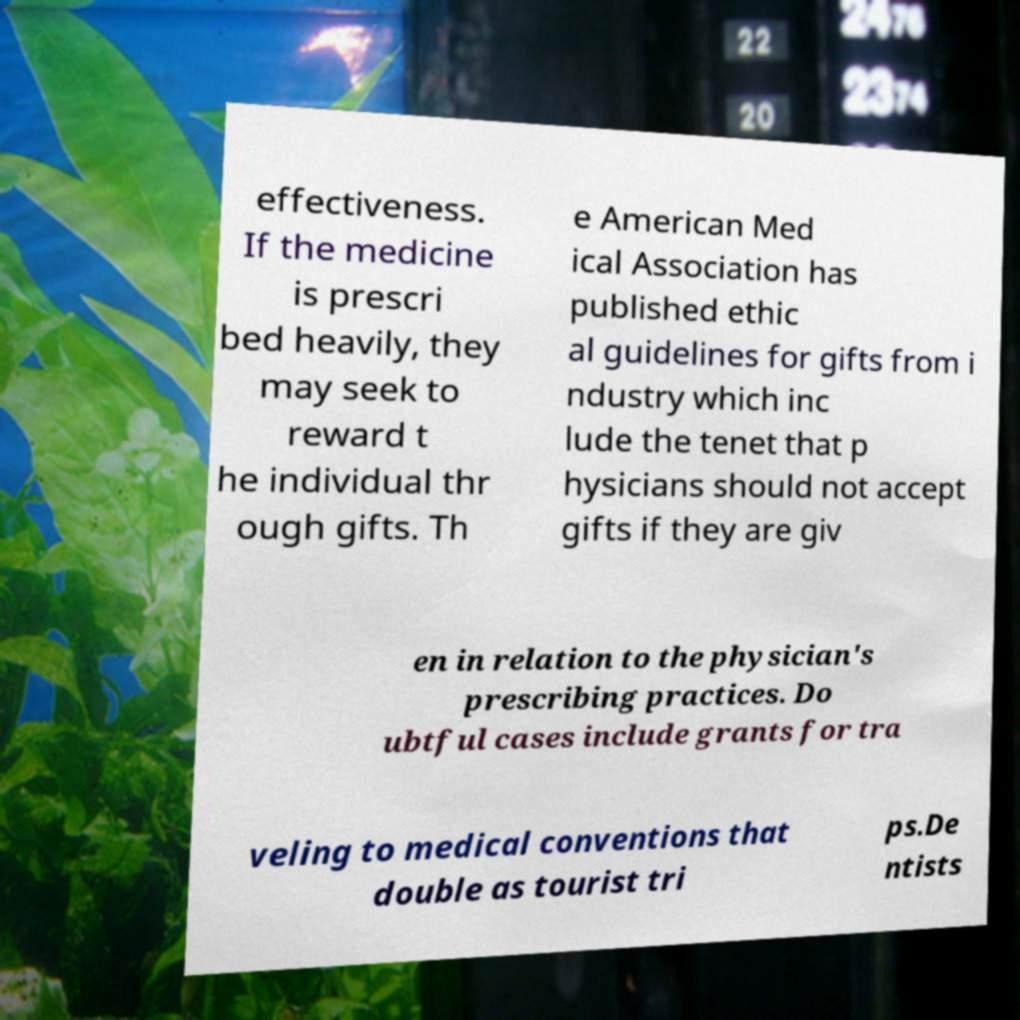Can you accurately transcribe the text from the provided image for me? effectiveness. If the medicine is prescri bed heavily, they may seek to reward t he individual thr ough gifts. Th e American Med ical Association has published ethic al guidelines for gifts from i ndustry which inc lude the tenet that p hysicians should not accept gifts if they are giv en in relation to the physician's prescribing practices. Do ubtful cases include grants for tra veling to medical conventions that double as tourist tri ps.De ntists 